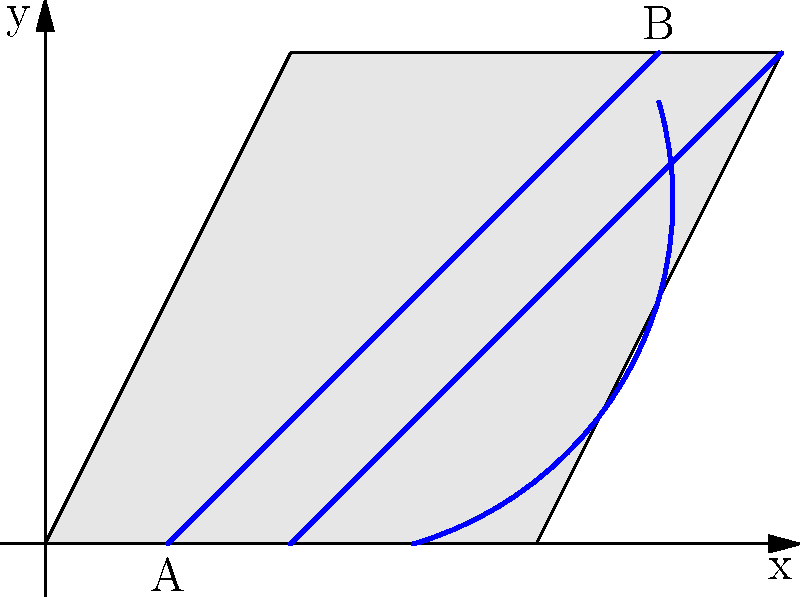Given the stress trajectories in the dam cross-section shown above, determine the components of the stress tensor $\sigma_{ij}$ at point B if the principal stresses at point A are $\sigma_1 = 100$ kPa and $\sigma_2 = 50$ kPa, and the stress tensor rotates by $\frac{\pi}{4}$ radians counterclockwise from A to B. Assume the stress magnitude remains constant along the trajectories. To solve this problem, we'll follow these steps:

1) First, recall that the stress tensor at point A can be written as:

   $$\sigma_{ij}^A = \begin{pmatrix} 
   100 & 0 \\
   0 & 50
   \end{pmatrix}$$

2) The rotation of the stress tensor from A to B can be represented by a rotation matrix:

   $$R = \begin{pmatrix}
   \cos\frac{\pi}{4} & -\sin\frac{\pi}{4} \\
   \sin\frac{\pi}{4} & \cos\frac{\pi}{4}
   \end{pmatrix} = \frac{1}{\sqrt{2}}\begin{pmatrix}
   1 & -1 \\
   1 & 1
   \end{pmatrix}$$

3) The stress tensor at B can be calculated using the tensor transformation law:

   $$\sigma_{ij}^B = R_{ik}\sigma_{kl}^AR_{jl}^T$$

4) Let's perform this multiplication step by step:

   $$\sigma_{ij}^B = \frac{1}{\sqrt{2}}\begin{pmatrix}
   1 & -1 \\
   1 & 1
   \end{pmatrix} \begin{pmatrix} 
   100 & 0 \\
   0 & 50
   \end{pmatrix} \frac{1}{\sqrt{2}}\begin{pmatrix}
   1 & 1 \\
   -1 & 1
   \end{pmatrix}$$

5) Multiplying the first two matrices:

   $$\frac{1}{\sqrt{2}}\begin{pmatrix}
   100 & -50 \\
   100 & 50
   \end{pmatrix} \frac{1}{\sqrt{2}}\begin{pmatrix}
   1 & 1 \\
   -1 & 1
   \end{pmatrix}$$

6) Completing the multiplication:

   $$\frac{1}{2}\begin{pmatrix}
   150 & 50 \\
   50 & 150
   \end{pmatrix}$$

7) Therefore, the components of the stress tensor at point B are:

   $$\sigma_{ij}^B = \begin{pmatrix}
   75 & 25 \\
   25 & 75
   \end{pmatrix}$$
Answer: $\sigma_{ij}^B = \begin{pmatrix} 75 & 25 \\ 25 & 75 \end{pmatrix}$ kPa 